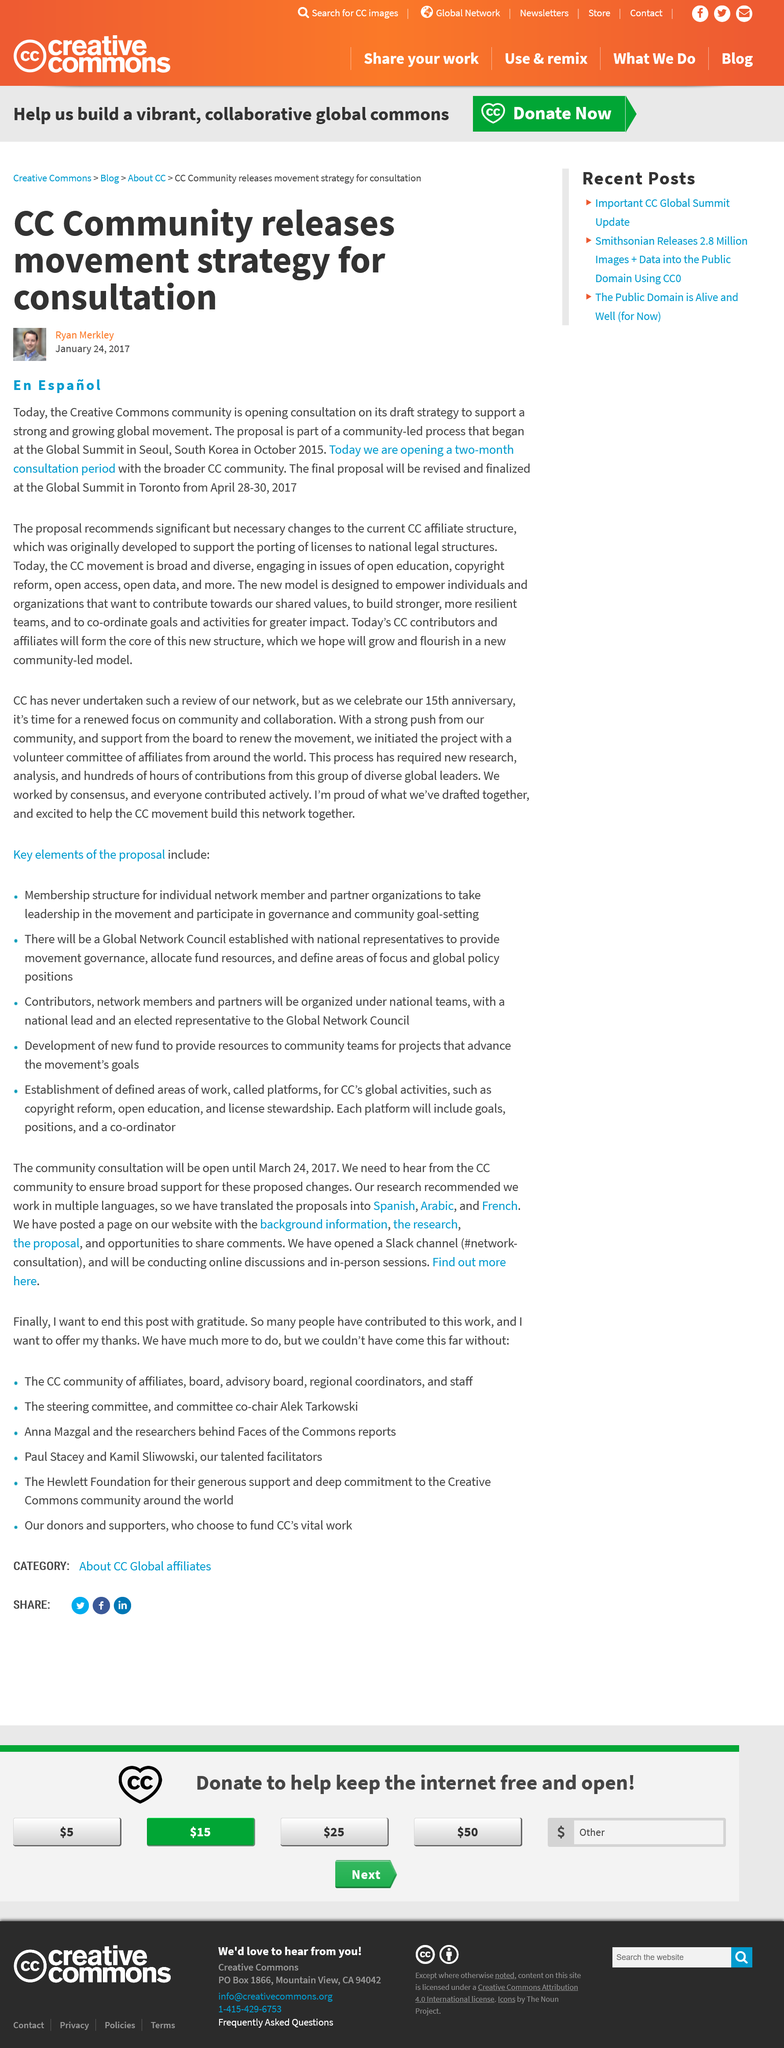Indicate a few pertinent items in this graphic. The article is also available in Spanish. The abbreviation 'CC' in relation to this article stands for Creative Commons. The final proposal will be finalized during the period of April 28-30, 2017. 